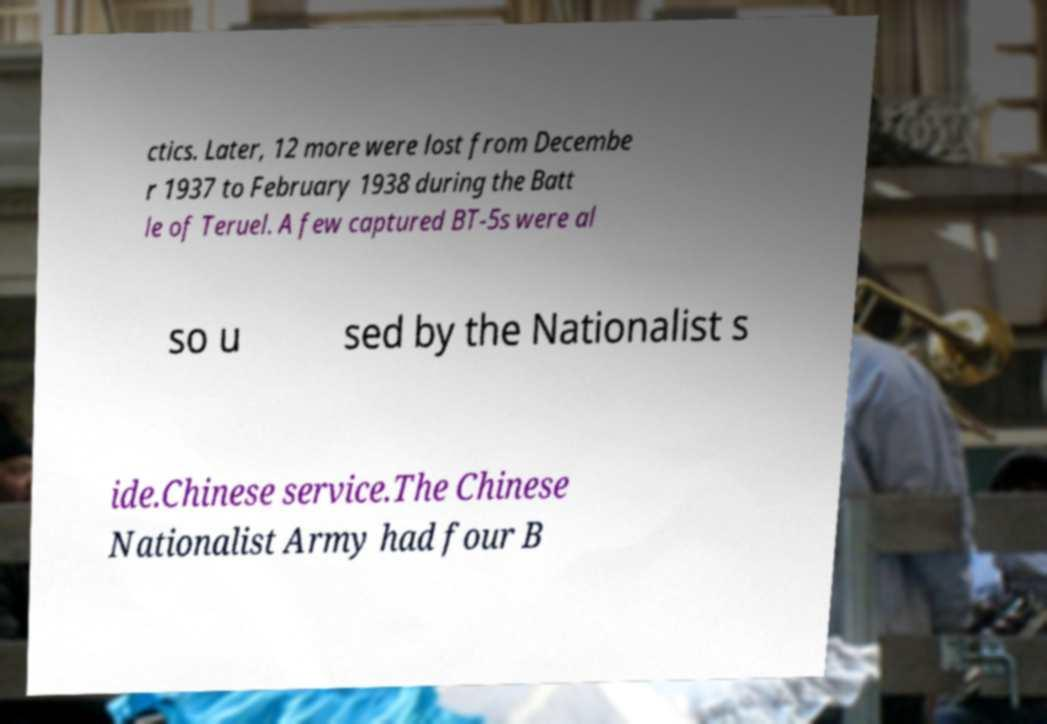Can you accurately transcribe the text from the provided image for me? ctics. Later, 12 more were lost from Decembe r 1937 to February 1938 during the Batt le of Teruel. A few captured BT-5s were al so u sed by the Nationalist s ide.Chinese service.The Chinese Nationalist Army had four B 